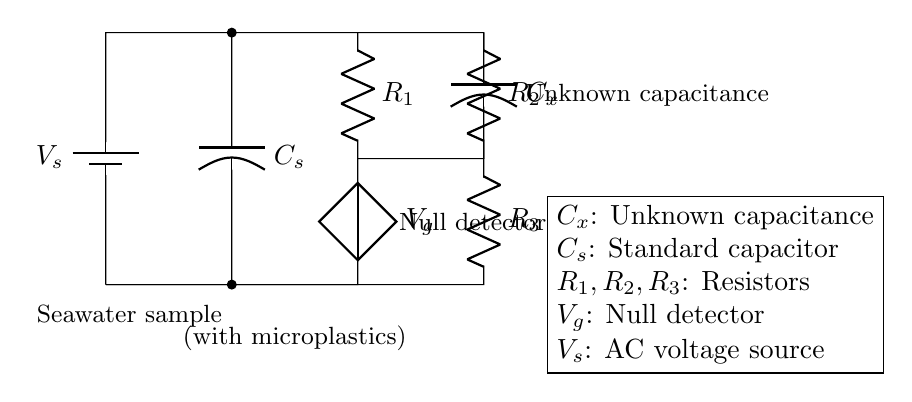What are the resistors in this circuit? The circuit contains three resistors labeled as R1, R2, and R3.
Answer: R1, R2, R3 What is the purpose of Cx? Cx is the unknown capacitance which is being measured to detect microplastics in the seawater sample.
Answer: Unknown capacitance How many capacitors are in this circuit? There are two capacitors: Cx and Cs.
Answer: Two What is the voltage source in the circuit? The voltage source is labeled as Vs, providing an alternating current to the circuit.
Answer: Vs What is the role of Vg in the circuit? Vg is a null detector that helps to determine when the bridge is balanced, indicating that the unknown capacitance matches the standard capacitor.
Answer: Null detector Explain how the circuit detects the presence of microplastics. The circuit operates as a capacitance bridge, where the value of the unknown capacitance (Cx) changes in the presence of microplastics. By comparing Cx with the standard capacitor (Cs) and observing the output of the null detector (Vg), variations in capacitance can indicate the presence of microplastics in the seawater sample.
Answer: Capacitance bridge What is the significance of the connection with the seawater sample? The connection represents the introduction of the seawater sample into the circuit, allowing for the measurement of its capacitance and thereby detecting microplastics contained within it.
Answer: Seawater sample 